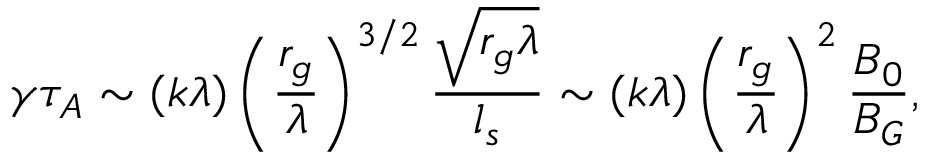<formula> <loc_0><loc_0><loc_500><loc_500>\gamma \tau _ { A } \sim ( k \lambda ) \left ( \frac { r _ { g } } { \lambda } \right ) ^ { 3 / 2 } \frac { \sqrt { r _ { g } \lambda } } { l _ { s } } \sim ( k \lambda ) \left ( \frac { r _ { g } } { \lambda } \right ) ^ { 2 } \frac { B _ { 0 } } { B _ { G } } ,</formula> 